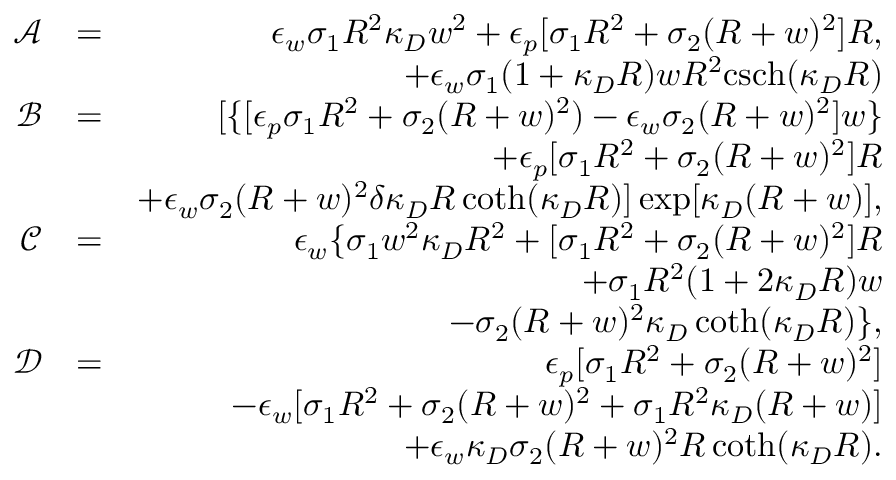Convert formula to latex. <formula><loc_0><loc_0><loc_500><loc_500>\begin{array} { r l r } { \mathcal { A } } & { = } & { \epsilon _ { w } \sigma _ { 1 } R ^ { 2 } \kappa _ { D } w ^ { 2 } + \epsilon _ { p } [ \sigma _ { 1 } R ^ { 2 } + \sigma _ { 2 } ( R + w ) ^ { 2 } ] R , } \\ & { + \epsilon _ { w } \sigma _ { 1 } ( 1 + \kappa _ { D } R ) w R ^ { 2 } c s c h ( \kappa _ { D } R ) } \\ { \mathcal { B } } & { = } & { [ \{ [ \epsilon _ { p } \sigma _ { 1 } R ^ { 2 } + \sigma _ { 2 } ( R + w ) ^ { 2 } ) - \epsilon _ { w } \sigma _ { 2 } ( R + w ) ^ { 2 } ] w \} } \\ & { + \epsilon _ { p } [ \sigma _ { 1 } R ^ { 2 } + \sigma _ { 2 } ( R + w ) ^ { 2 } ] R } \\ & { + \epsilon _ { w } \sigma _ { 2 } ( R + w ) ^ { 2 } \delta \kappa _ { D } R \coth ( \kappa _ { D } R ) ] \exp [ \kappa _ { D } ( R + w ) ] , } \\ { \mathcal { C } } & { = } & { \epsilon _ { w } \{ \sigma _ { 1 } w ^ { 2 } \kappa _ { D } R ^ { 2 } + [ \sigma _ { 1 } R ^ { 2 } + \sigma _ { 2 } ( R + w ) ^ { 2 } ] R } \\ & { + \sigma _ { 1 } R ^ { 2 } ( 1 + 2 \kappa _ { D } R ) w } \\ & { - \sigma _ { 2 } ( R + w ) ^ { 2 } \kappa _ { D } \coth ( \kappa _ { D } R ) \} , } \\ { \mathcal { D } } & { = } & { \epsilon _ { p } [ \sigma _ { 1 } R ^ { 2 } + \sigma _ { 2 } ( R + w ) ^ { 2 } ] } \\ & { - \epsilon _ { w } [ \sigma _ { 1 } R ^ { 2 } + \sigma _ { 2 } ( R + w ) ^ { 2 } + \sigma _ { 1 } R ^ { 2 } \kappa _ { D } ( R + w ) ] } \\ & { + \epsilon _ { w } \kappa _ { D } \sigma _ { 2 } ( R + w ) ^ { 2 } R \coth ( \kappa _ { D } R ) . } \end{array}</formula> 